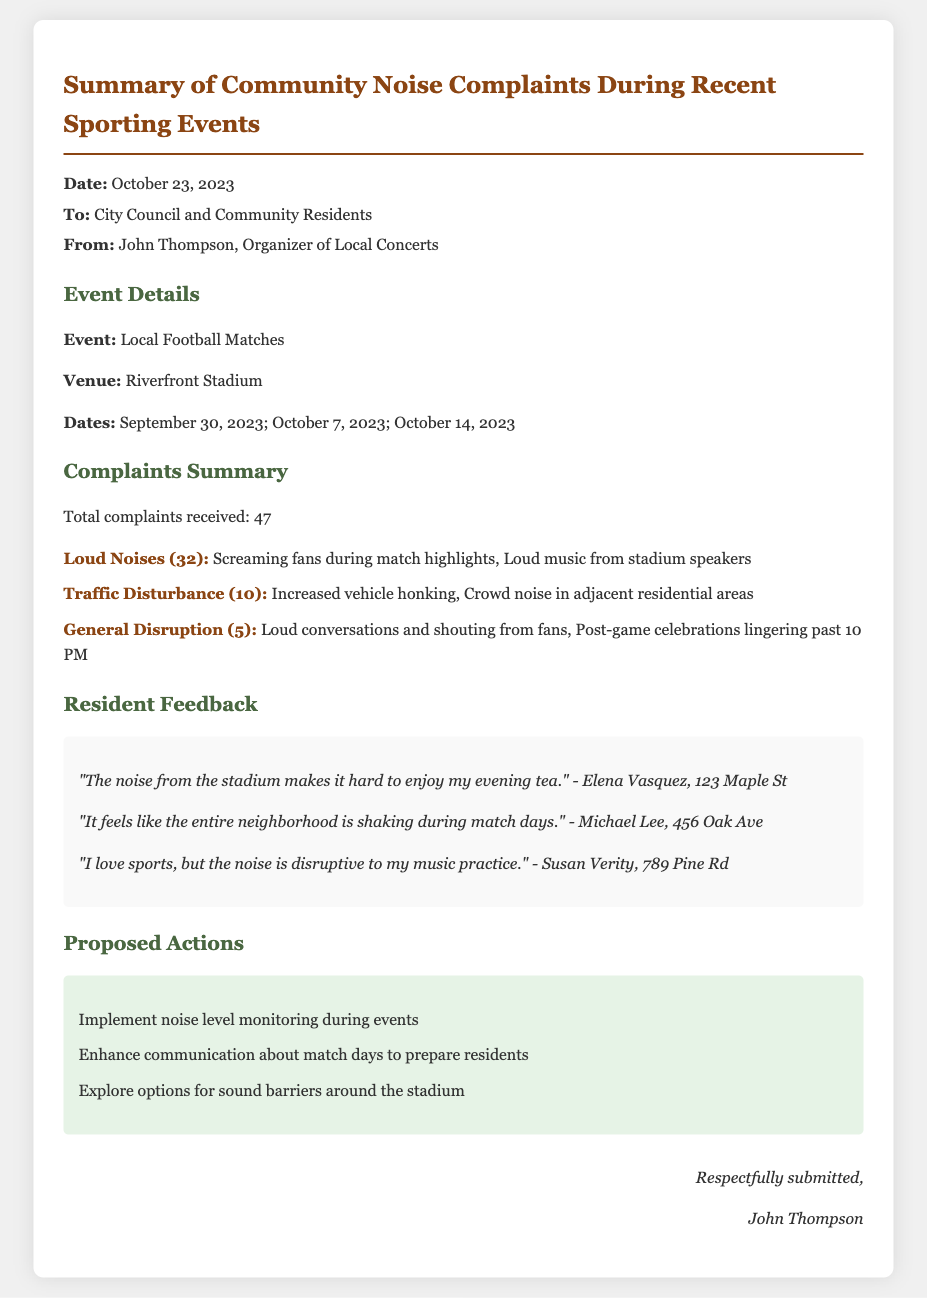What is the date of the memo? The date of the memo is stated at the beginning of the document.
Answer: October 23, 2023 Who is the memo addressed to? The memo specifies the recipients in the header section.
Answer: City Council and Community Residents How many total complaints were received? The total number of complaints is clearly presented in the Complaints Summary section.
Answer: 47 What was one type of loud noise mentioned? The document lists specific types of loud noises under the Complaints Summary.
Answer: Screaming fans during match highlights How many complaints were related to traffic disturbance? The number of complaints regarding traffic disturbance is provided in the list of complaints.
Answer: 10 What are the proposed actions mentioned? The document includes specific proposals in the Proposed Actions section.
Answer: Implement noise level monitoring during events Who expressed that the noise disrupts their music practice? A resident's feedback regarding noise disruption is provided in the Resident Feedback section.
Answer: Susan Verity What was the venue for the sporting events? The venue where the events took place is stated in the Event Details section.
Answer: Riverfront Stadium What kind of feedback did Elena Vasquez provide? The feedback from residents highlights personal experiences with noise, reflecting their sentiments.
Answer: "The noise from the stadium makes it hard to enjoy my evening tea." 